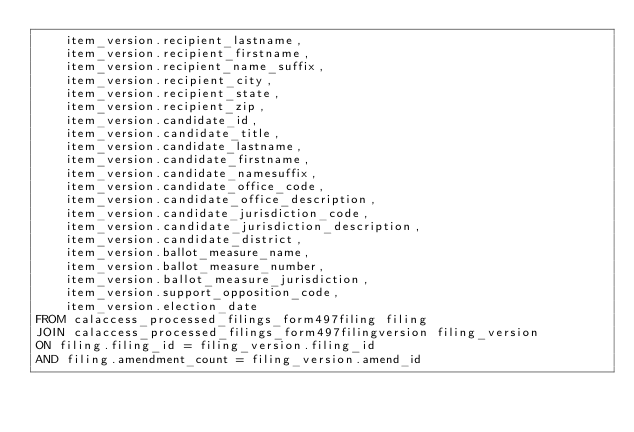<code> <loc_0><loc_0><loc_500><loc_500><_SQL_>    item_version.recipient_lastname,
    item_version.recipient_firstname,
    item_version.recipient_name_suffix,
    item_version.recipient_city,
    item_version.recipient_state,
    item_version.recipient_zip,
    item_version.candidate_id,
    item_version.candidate_title,
    item_version.candidate_lastname,
    item_version.candidate_firstname,
    item_version.candidate_namesuffix,
    item_version.candidate_office_code,
    item_version.candidate_office_description,
    item_version.candidate_jurisdiction_code,
    item_version.candidate_jurisdiction_description,
    item_version.candidate_district,
    item_version.ballot_measure_name,
    item_version.ballot_measure_number,
    item_version.ballot_measure_jurisdiction,
    item_version.support_opposition_code,
    item_version.election_date
FROM calaccess_processed_filings_form497filing filing
JOIN calaccess_processed_filings_form497filingversion filing_version
ON filing.filing_id = filing_version.filing_id
AND filing.amendment_count = filing_version.amend_id</code> 